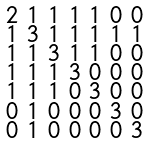<formula> <loc_0><loc_0><loc_500><loc_500>\begin{smallmatrix} 2 & 1 & 1 & 1 & 1 & 0 & 0 \\ 1 & 3 & 1 & 1 & 1 & 1 & 1 \\ 1 & 1 & 3 & 1 & 1 & 0 & 0 \\ 1 & 1 & 1 & 3 & 0 & 0 & 0 \\ 1 & 1 & 1 & 0 & 3 & 0 & 0 \\ 0 & 1 & 0 & 0 & 0 & 3 & 0 \\ 0 & 1 & 0 & 0 & 0 & 0 & 3 \end{smallmatrix}</formula> 